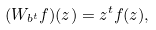Convert formula to latex. <formula><loc_0><loc_0><loc_500><loc_500>( W _ { b ^ { t } } f ) ( z ) = z ^ { t } f ( z ) ,</formula> 